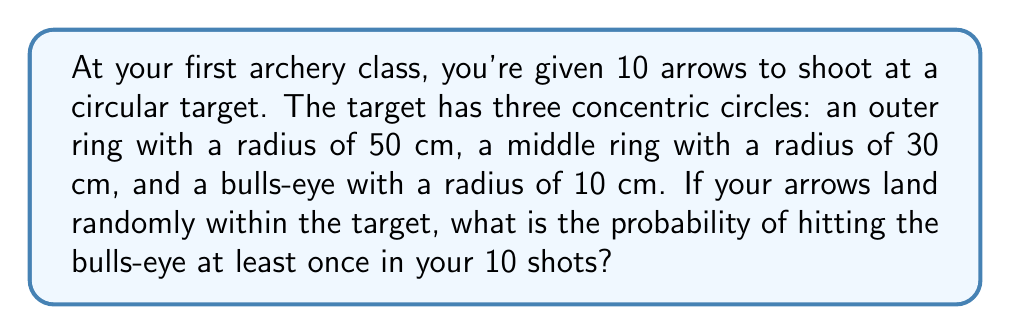Can you answer this question? Let's approach this step-by-step:

1) First, we need to calculate the probability of hitting the bulls-eye on a single shot.

   Area of the entire target: $A_t = \pi r^2 = \pi (50)^2 = 2500\pi$ cm²
   Area of the bulls-eye: $A_b = \pi r^2 = \pi (10)^2 = 100\pi$ cm²

   Probability of hitting bulls-eye on one shot: 
   $P(\text{bulls-eye}) = \frac{A_b}{A_t} = \frac{100\pi}{2500\pi} = \frac{1}{25} = 0.04$

2) Now, we need to find the probability of hitting the bulls-eye at least once in 10 shots.
   It's easier to calculate the probability of not hitting the bulls-eye at all and then subtract from 1.

3) Probability of not hitting the bulls-eye on one shot: $1 - 0.04 = 0.96$

4) Probability of not hitting the bulls-eye on all 10 shots: $(0.96)^{10}$

5) Therefore, the probability of hitting the bulls-eye at least once is:

   $P(\text{at least one bulls-eye}) = 1 - P(\text{no bulls-eye})$
   $= 1 - (0.96)^{10}$
   $= 1 - 0.6695$
   $= 0.3305$

6) Converting to a percentage: $0.3305 * 100 = 33.05\%$
Answer: $33.05\%$ 